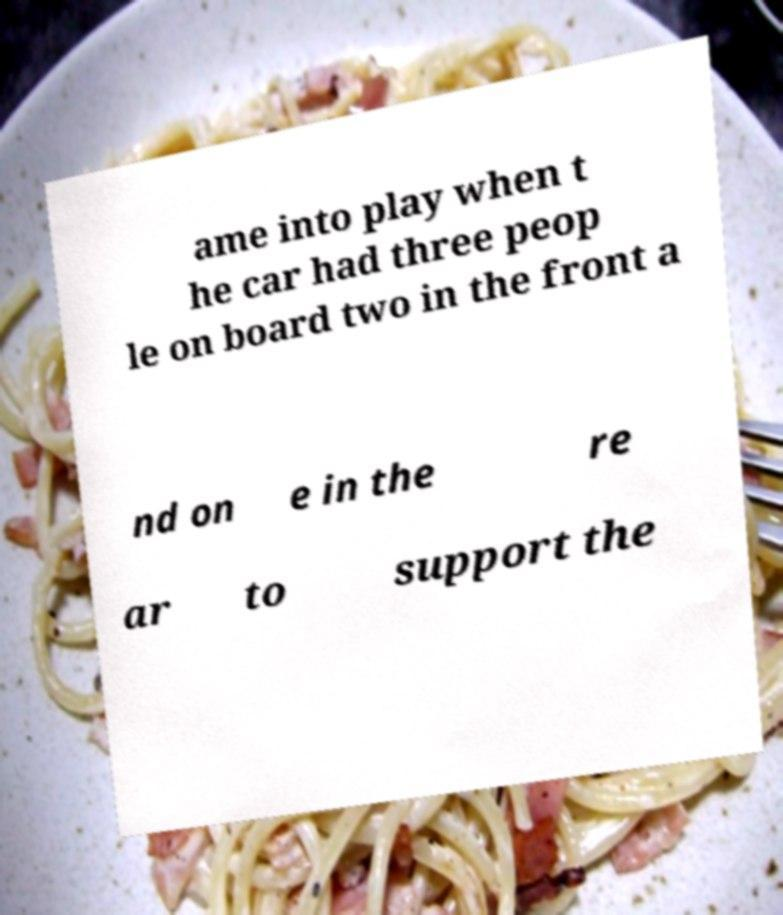For documentation purposes, I need the text within this image transcribed. Could you provide that? ame into play when t he car had three peop le on board two in the front a nd on e in the re ar to support the 